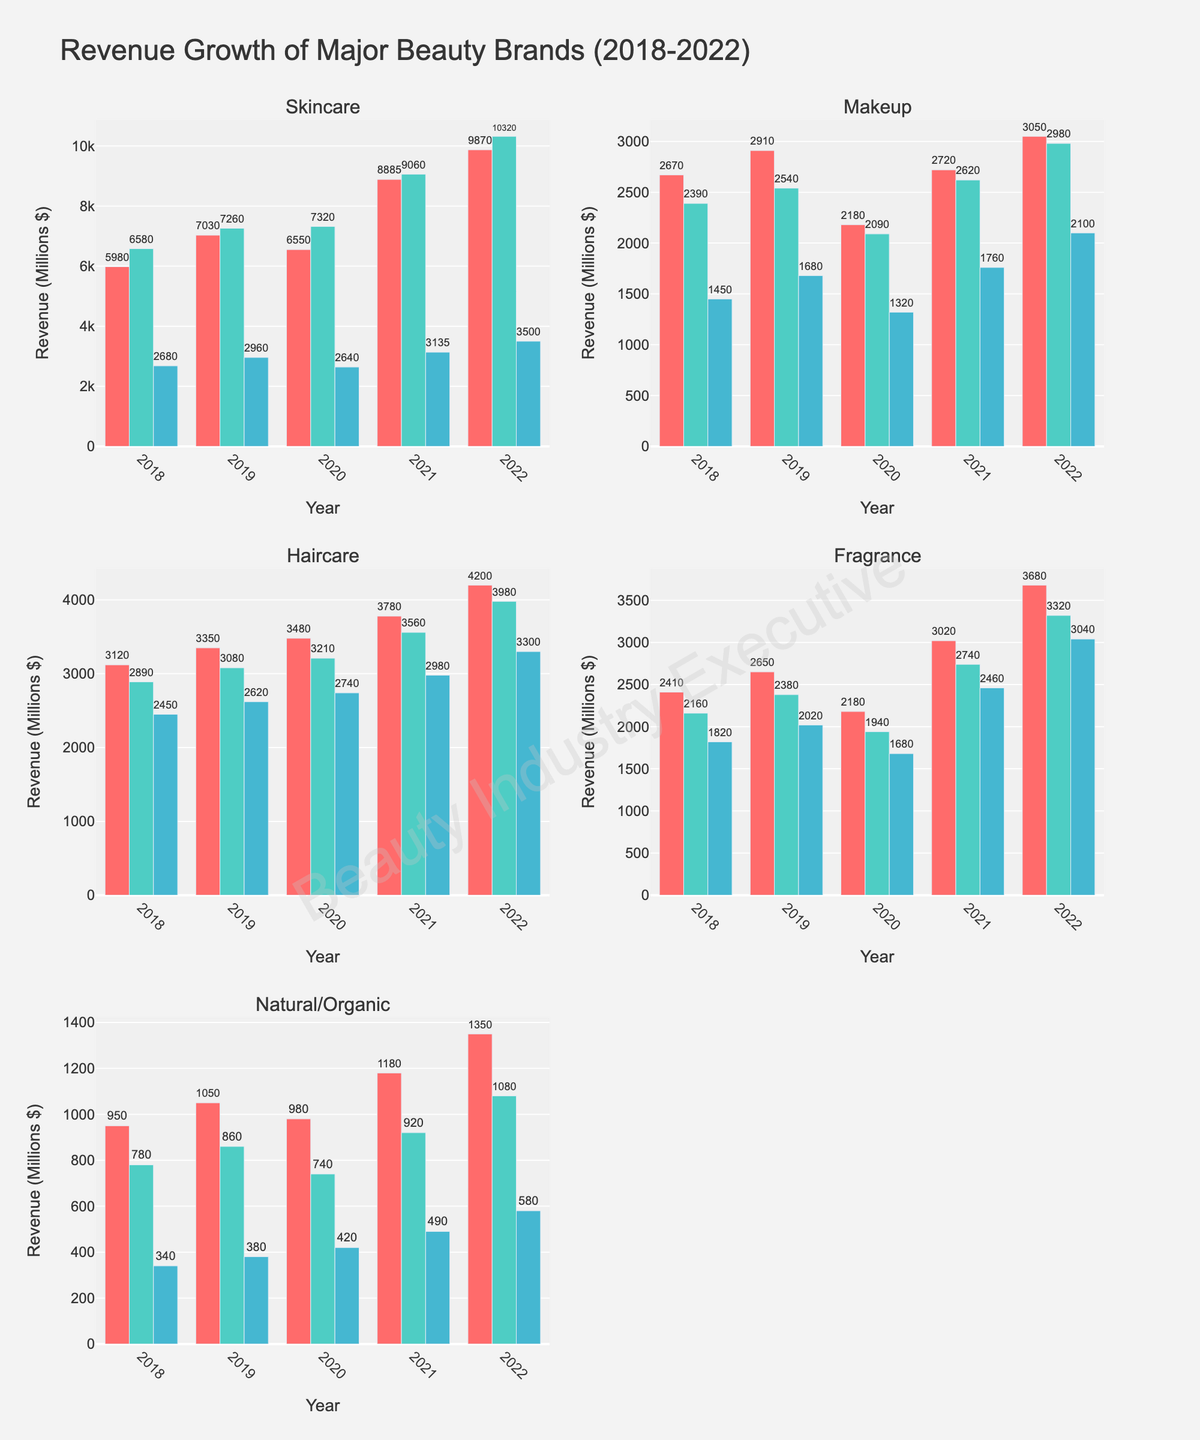Which brand in Skincare had the highest revenue growth between 2021 and 2022? First, identify the Skincare product type in the figure. Then, compare the revenue of Estée Lauder, L'Oréal, and Shiseido in 2021 and 2022. Estée Lauder had the highest revenue growth from $8885 million to $9870 million.
Answer: Estée Lauder Which makeup brand experienced the lowest revenue in 2020? Look at the Makeup product type and compare the revenue of MAC Cosmetics, Maybelline, and NARS for the year 2020. NARS had the lowest revenue with $1320 million.
Answer: NARS What is the average revenue for Haircare brands in 2022? Identify the Haircare product type and sum the revenue of Pantene, L'Oréal Paris, and Head & Shoulders for 2022: $4200 million + $3980 million + $3300 million = $11480 million. Then divide by 3, which gives an average revenue of $3826.67 million.
Answer: $3826.67 million Which Fragrance brand showed the biggest increase in revenue from 2018 to 2022? For the Fragrance product type, compare the revenue figures for Chanel, Dior, and Gucci from 2018 to 2022. Calculate the difference for each brand: Chanel ($3680-$2410=$1270 million), Dior ($3320-$2160=$1160 million), Gucci ($3040-$1820=$1220 million). Chanel had the highest increase.
Answer: Chanel Which year did Estée Lauder experience the highest revenue? Focus on the Estée Lauder brand in the Skincare product type. Check the revenues from 2018 to 2022. The highest revenue is in 2022 with $9870 million.
Answer: 2022 How does the total revenue for Natural/Organic products in 2020 compare to that in 2021? Sum the revenue for The Body Shop, Aveda, and Burt's Bees in 2020 ($980 + $740 + $420 = $2140 million) and in 2021 ($1180 + $920 + $490 = $2590 million). The revenue in 2021 is higher by $450 million.
Answer: 2021 is higher by $450 million What was the revenue growth for Maybelline from 2019 to 2022? Look at the Makeup product type and find Maybelline's revenue in 2019 and 2022. Calculate the growth: $2980 million (2022) - $2540 million (2019) = $440 million.
Answer: $440 million Compare the revenue of L'Oréal Paris and Pantene in 2020. Which one was higher? Identify the revenues for L'Oréal Paris and Pantene within the Haircare product type in 2020. L'Oréal Paris had $3210 million and Pantene had $3480 million. Pantene's revenue was higher.
Answer: Pantene Which Skincare brand consistently increased its revenue every year from 2018 to 2022? Analyze the revenue trends for Estée Lauder, L'Oréal, and Shiseido within the Skincare product type. L'Oréal's revenue increased consistently every year from $6580 million in 2018 to $10320 million in 2022.
Answer: L'Oréal 